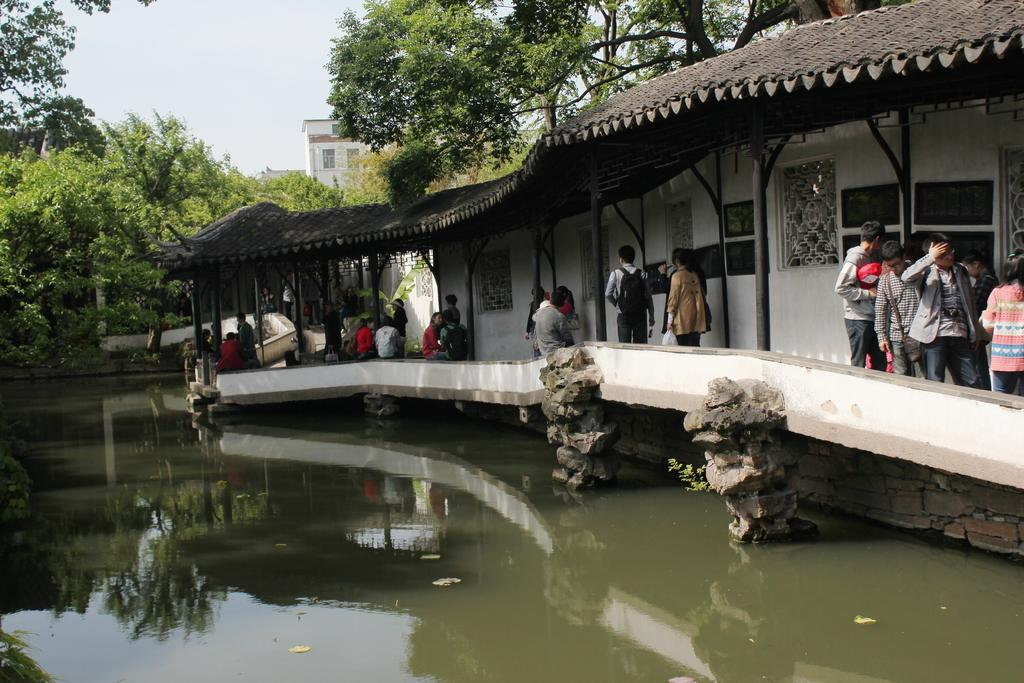Where are the persons located in the image? The persons are in the right corner of the image. What is near the persons in the image? There is water beside the persons. What can be seen in the background of the image? There are trees and a building in the background of the image. How many babies are crawling on the shop in the image? There are no babies or shops present in the image. Is there a hose connected to the building in the image? There is no hose visible in the image. 